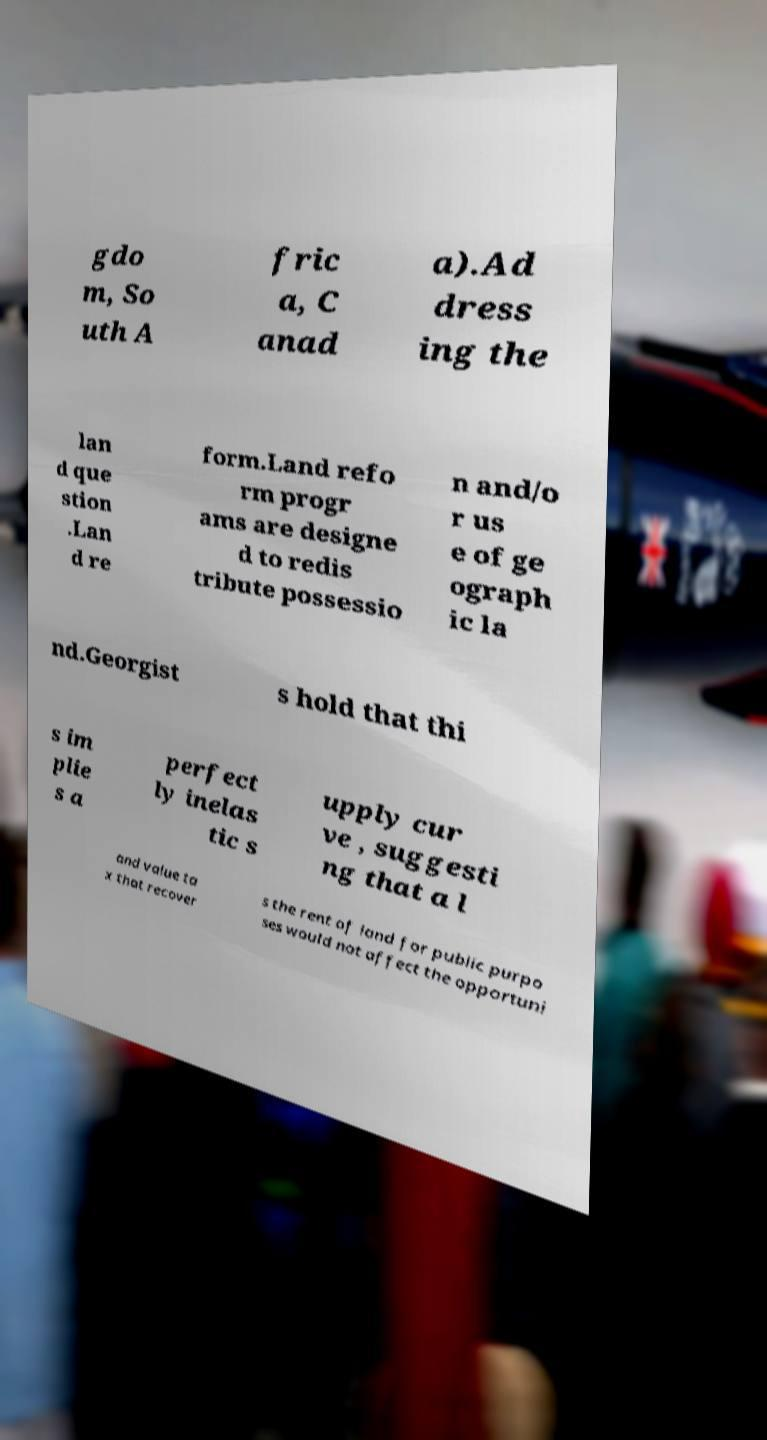Could you assist in decoding the text presented in this image and type it out clearly? gdo m, So uth A fric a, C anad a).Ad dress ing the lan d que stion .Lan d re form.Land refo rm progr ams are designe d to redis tribute possessio n and/o r us e of ge ograph ic la nd.Georgist s hold that thi s im plie s a perfect ly inelas tic s upply cur ve , suggesti ng that a l and value ta x that recover s the rent of land for public purpo ses would not affect the opportuni 